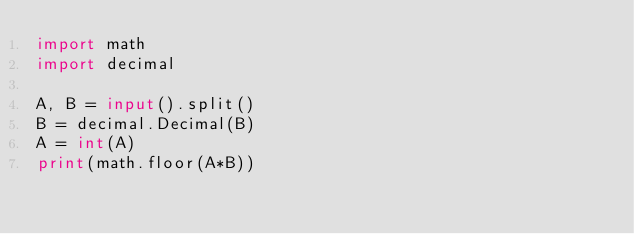<code> <loc_0><loc_0><loc_500><loc_500><_Python_>import math
import decimal

A, B = input().split()
B = decimal.Decimal(B)
A = int(A)
print(math.floor(A*B))</code> 